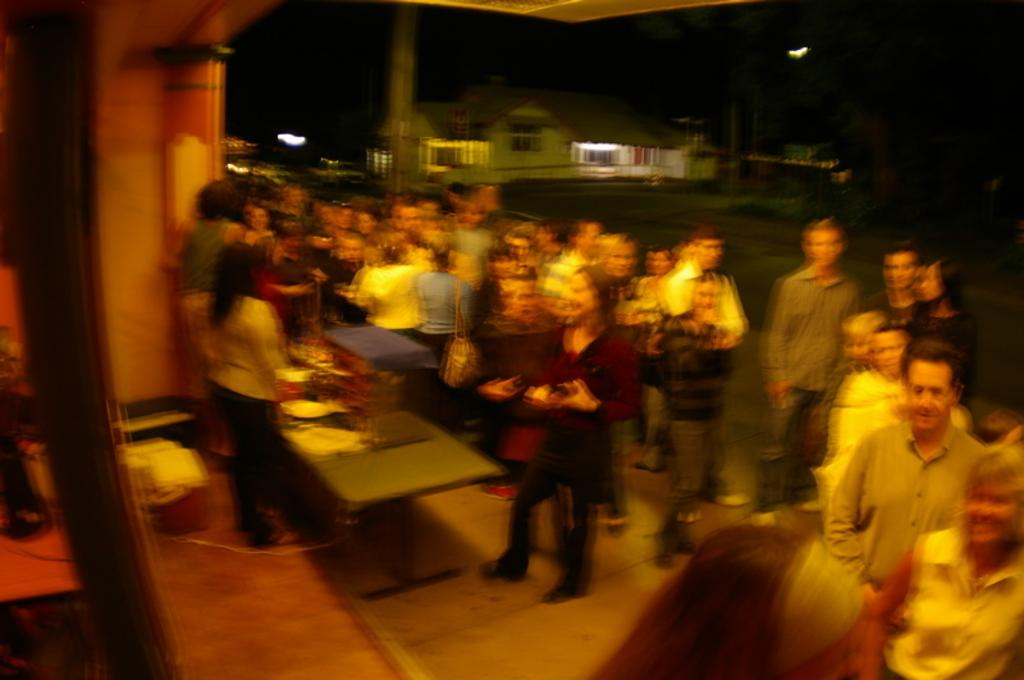How many persons are visible in the image? There are persons standing in the image. Can you describe the position of two of the persons? Two persons are standing in front of a table. What is on the table in the image? The table has objects on it. What can be seen in the background of the image? There is a house and trees in the background of the image. What type of lumber is being used for the table in the image? There is no information about the type of lumber used for the table in the image. How does the digestion process of the persons in the image appear to be? There is no information about the digestion process of the persons in the image. 